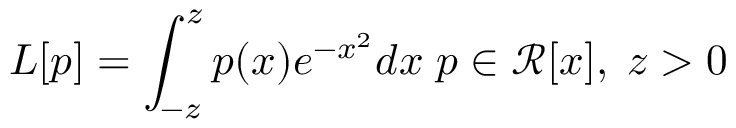<formula> <loc_0><loc_0><loc_500><loc_500>L [ p ] = \int _ { - z } ^ { z } p ( x ) e ^ { - x ^ { 2 } } d x \, p \in \mathcal { R } [ x ] , \, z > 0</formula> 